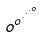<formula> <loc_0><loc_0><loc_500><loc_500>o ^ { o ^ { \cdot ^ { \cdot ^ { \cdot ^ { o } } } } }</formula> 